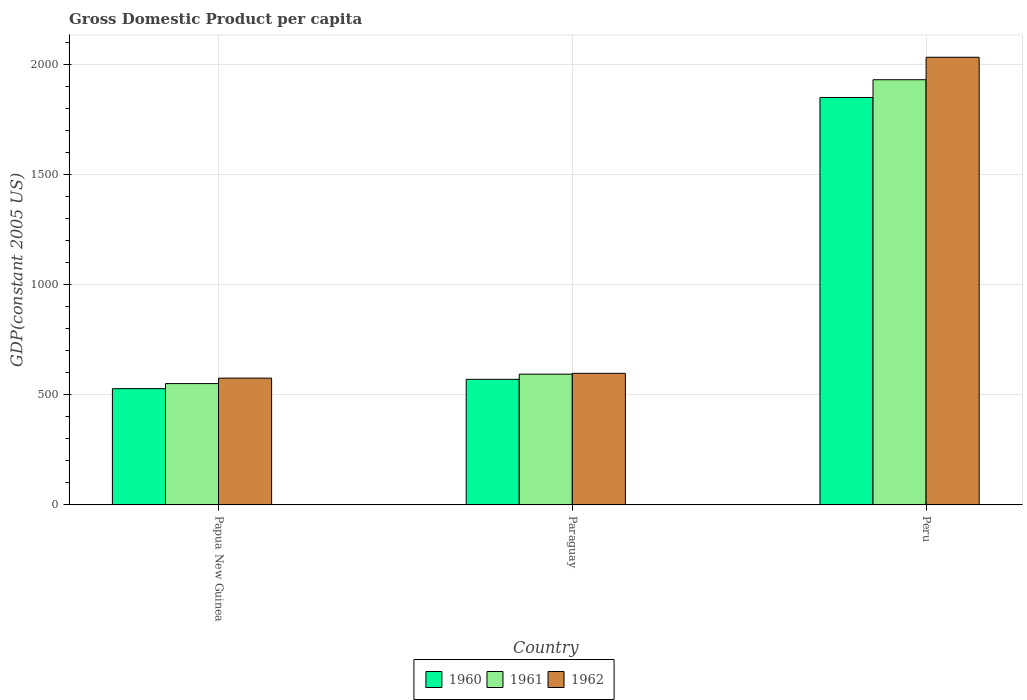How many different coloured bars are there?
Your answer should be very brief. 3. How many groups of bars are there?
Your answer should be very brief. 3. Are the number of bars per tick equal to the number of legend labels?
Provide a succinct answer. Yes. How many bars are there on the 2nd tick from the right?
Give a very brief answer. 3. What is the label of the 3rd group of bars from the left?
Provide a succinct answer. Peru. What is the GDP per capita in 1960 in Peru?
Offer a terse response. 1851.77. Across all countries, what is the maximum GDP per capita in 1962?
Your answer should be compact. 2034.54. Across all countries, what is the minimum GDP per capita in 1960?
Provide a succinct answer. 528.4. In which country was the GDP per capita in 1962 minimum?
Give a very brief answer. Papua New Guinea. What is the total GDP per capita in 1961 in the graph?
Give a very brief answer. 3078.31. What is the difference between the GDP per capita in 1961 in Papua New Guinea and that in Paraguay?
Give a very brief answer. -42.88. What is the difference between the GDP per capita in 1961 in Papua New Guinea and the GDP per capita in 1962 in Peru?
Keep it short and to the point. -1483.04. What is the average GDP per capita in 1960 per country?
Offer a very short reply. 983.64. What is the difference between the GDP per capita of/in 1960 and GDP per capita of/in 1962 in Peru?
Your answer should be very brief. -182.77. What is the ratio of the GDP per capita in 1961 in Papua New Guinea to that in Peru?
Make the answer very short. 0.29. Is the GDP per capita in 1962 in Paraguay less than that in Peru?
Provide a succinct answer. Yes. What is the difference between the highest and the second highest GDP per capita in 1961?
Make the answer very short. -1338.04. What is the difference between the highest and the lowest GDP per capita in 1962?
Give a very brief answer. 1458.28. In how many countries, is the GDP per capita in 1960 greater than the average GDP per capita in 1960 taken over all countries?
Offer a very short reply. 1. Is the sum of the GDP per capita in 1962 in Paraguay and Peru greater than the maximum GDP per capita in 1961 across all countries?
Provide a succinct answer. Yes. What does the 2nd bar from the right in Papua New Guinea represents?
Give a very brief answer. 1961. Is it the case that in every country, the sum of the GDP per capita in 1962 and GDP per capita in 1961 is greater than the GDP per capita in 1960?
Give a very brief answer. Yes. How many bars are there?
Give a very brief answer. 9. Does the graph contain any zero values?
Your response must be concise. No. Where does the legend appear in the graph?
Your answer should be very brief. Bottom center. How are the legend labels stacked?
Ensure brevity in your answer.  Horizontal. What is the title of the graph?
Your answer should be very brief. Gross Domestic Product per capita. Does "1964" appear as one of the legend labels in the graph?
Give a very brief answer. No. What is the label or title of the X-axis?
Provide a short and direct response. Country. What is the label or title of the Y-axis?
Provide a succinct answer. GDP(constant 2005 US). What is the GDP(constant 2005 US) in 1960 in Papua New Guinea?
Give a very brief answer. 528.4. What is the GDP(constant 2005 US) of 1961 in Papua New Guinea?
Your answer should be very brief. 551.5. What is the GDP(constant 2005 US) of 1962 in Papua New Guinea?
Keep it short and to the point. 576.26. What is the GDP(constant 2005 US) of 1960 in Paraguay?
Make the answer very short. 570.76. What is the GDP(constant 2005 US) of 1961 in Paraguay?
Offer a terse response. 594.38. What is the GDP(constant 2005 US) in 1962 in Paraguay?
Give a very brief answer. 598.08. What is the GDP(constant 2005 US) of 1960 in Peru?
Your answer should be compact. 1851.77. What is the GDP(constant 2005 US) of 1961 in Peru?
Make the answer very short. 1932.43. What is the GDP(constant 2005 US) of 1962 in Peru?
Your answer should be very brief. 2034.54. Across all countries, what is the maximum GDP(constant 2005 US) in 1960?
Offer a very short reply. 1851.77. Across all countries, what is the maximum GDP(constant 2005 US) of 1961?
Provide a succinct answer. 1932.43. Across all countries, what is the maximum GDP(constant 2005 US) in 1962?
Keep it short and to the point. 2034.54. Across all countries, what is the minimum GDP(constant 2005 US) in 1960?
Make the answer very short. 528.4. Across all countries, what is the minimum GDP(constant 2005 US) of 1961?
Offer a terse response. 551.5. Across all countries, what is the minimum GDP(constant 2005 US) in 1962?
Your answer should be very brief. 576.26. What is the total GDP(constant 2005 US) of 1960 in the graph?
Offer a terse response. 2950.93. What is the total GDP(constant 2005 US) of 1961 in the graph?
Make the answer very short. 3078.31. What is the total GDP(constant 2005 US) of 1962 in the graph?
Keep it short and to the point. 3208.87. What is the difference between the GDP(constant 2005 US) in 1960 in Papua New Guinea and that in Paraguay?
Provide a succinct answer. -42.36. What is the difference between the GDP(constant 2005 US) in 1961 in Papua New Guinea and that in Paraguay?
Ensure brevity in your answer.  -42.88. What is the difference between the GDP(constant 2005 US) of 1962 in Papua New Guinea and that in Paraguay?
Ensure brevity in your answer.  -21.82. What is the difference between the GDP(constant 2005 US) in 1960 in Papua New Guinea and that in Peru?
Make the answer very short. -1323.37. What is the difference between the GDP(constant 2005 US) in 1961 in Papua New Guinea and that in Peru?
Offer a very short reply. -1380.92. What is the difference between the GDP(constant 2005 US) in 1962 in Papua New Guinea and that in Peru?
Offer a very short reply. -1458.28. What is the difference between the GDP(constant 2005 US) of 1960 in Paraguay and that in Peru?
Ensure brevity in your answer.  -1281.01. What is the difference between the GDP(constant 2005 US) in 1961 in Paraguay and that in Peru?
Keep it short and to the point. -1338.04. What is the difference between the GDP(constant 2005 US) of 1962 in Paraguay and that in Peru?
Give a very brief answer. -1436.46. What is the difference between the GDP(constant 2005 US) of 1960 in Papua New Guinea and the GDP(constant 2005 US) of 1961 in Paraguay?
Keep it short and to the point. -65.98. What is the difference between the GDP(constant 2005 US) in 1960 in Papua New Guinea and the GDP(constant 2005 US) in 1962 in Paraguay?
Offer a terse response. -69.68. What is the difference between the GDP(constant 2005 US) in 1961 in Papua New Guinea and the GDP(constant 2005 US) in 1962 in Paraguay?
Your answer should be compact. -46.57. What is the difference between the GDP(constant 2005 US) of 1960 in Papua New Guinea and the GDP(constant 2005 US) of 1961 in Peru?
Make the answer very short. -1404.03. What is the difference between the GDP(constant 2005 US) of 1960 in Papua New Guinea and the GDP(constant 2005 US) of 1962 in Peru?
Offer a terse response. -1506.14. What is the difference between the GDP(constant 2005 US) in 1961 in Papua New Guinea and the GDP(constant 2005 US) in 1962 in Peru?
Your answer should be compact. -1483.04. What is the difference between the GDP(constant 2005 US) in 1960 in Paraguay and the GDP(constant 2005 US) in 1961 in Peru?
Offer a terse response. -1361.67. What is the difference between the GDP(constant 2005 US) of 1960 in Paraguay and the GDP(constant 2005 US) of 1962 in Peru?
Your answer should be compact. -1463.78. What is the difference between the GDP(constant 2005 US) in 1961 in Paraguay and the GDP(constant 2005 US) in 1962 in Peru?
Your answer should be very brief. -1440.15. What is the average GDP(constant 2005 US) in 1960 per country?
Keep it short and to the point. 983.64. What is the average GDP(constant 2005 US) in 1961 per country?
Provide a succinct answer. 1026.1. What is the average GDP(constant 2005 US) of 1962 per country?
Make the answer very short. 1069.62. What is the difference between the GDP(constant 2005 US) in 1960 and GDP(constant 2005 US) in 1961 in Papua New Guinea?
Your answer should be very brief. -23.1. What is the difference between the GDP(constant 2005 US) of 1960 and GDP(constant 2005 US) of 1962 in Papua New Guinea?
Provide a succinct answer. -47.85. What is the difference between the GDP(constant 2005 US) in 1961 and GDP(constant 2005 US) in 1962 in Papua New Guinea?
Give a very brief answer. -24.75. What is the difference between the GDP(constant 2005 US) in 1960 and GDP(constant 2005 US) in 1961 in Paraguay?
Offer a very short reply. -23.62. What is the difference between the GDP(constant 2005 US) of 1960 and GDP(constant 2005 US) of 1962 in Paraguay?
Give a very brief answer. -27.32. What is the difference between the GDP(constant 2005 US) of 1961 and GDP(constant 2005 US) of 1962 in Paraguay?
Make the answer very short. -3.69. What is the difference between the GDP(constant 2005 US) in 1960 and GDP(constant 2005 US) in 1961 in Peru?
Your answer should be compact. -80.65. What is the difference between the GDP(constant 2005 US) of 1960 and GDP(constant 2005 US) of 1962 in Peru?
Your answer should be very brief. -182.77. What is the difference between the GDP(constant 2005 US) of 1961 and GDP(constant 2005 US) of 1962 in Peru?
Offer a terse response. -102.11. What is the ratio of the GDP(constant 2005 US) in 1960 in Papua New Guinea to that in Paraguay?
Provide a succinct answer. 0.93. What is the ratio of the GDP(constant 2005 US) of 1961 in Papua New Guinea to that in Paraguay?
Your answer should be very brief. 0.93. What is the ratio of the GDP(constant 2005 US) in 1962 in Papua New Guinea to that in Paraguay?
Give a very brief answer. 0.96. What is the ratio of the GDP(constant 2005 US) in 1960 in Papua New Guinea to that in Peru?
Make the answer very short. 0.29. What is the ratio of the GDP(constant 2005 US) in 1961 in Papua New Guinea to that in Peru?
Make the answer very short. 0.29. What is the ratio of the GDP(constant 2005 US) of 1962 in Papua New Guinea to that in Peru?
Offer a terse response. 0.28. What is the ratio of the GDP(constant 2005 US) of 1960 in Paraguay to that in Peru?
Your response must be concise. 0.31. What is the ratio of the GDP(constant 2005 US) of 1961 in Paraguay to that in Peru?
Your response must be concise. 0.31. What is the ratio of the GDP(constant 2005 US) in 1962 in Paraguay to that in Peru?
Give a very brief answer. 0.29. What is the difference between the highest and the second highest GDP(constant 2005 US) of 1960?
Offer a very short reply. 1281.01. What is the difference between the highest and the second highest GDP(constant 2005 US) of 1961?
Give a very brief answer. 1338.04. What is the difference between the highest and the second highest GDP(constant 2005 US) in 1962?
Provide a short and direct response. 1436.46. What is the difference between the highest and the lowest GDP(constant 2005 US) of 1960?
Provide a short and direct response. 1323.37. What is the difference between the highest and the lowest GDP(constant 2005 US) in 1961?
Your answer should be compact. 1380.92. What is the difference between the highest and the lowest GDP(constant 2005 US) in 1962?
Offer a terse response. 1458.28. 